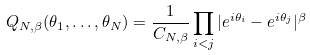<formula> <loc_0><loc_0><loc_500><loc_500>Q _ { N , \beta } ( \theta _ { 1 } , \dots , \theta _ { N } ) = \frac { 1 } { C _ { N , \beta } } \prod _ { i < j } | e ^ { i \theta _ { i } } - e ^ { i \theta _ { j } } | ^ { \beta }</formula> 